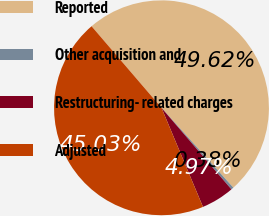Convert chart to OTSL. <chart><loc_0><loc_0><loc_500><loc_500><pie_chart><fcel>Reported<fcel>Other acquisition and<fcel>Restructuring- related charges<fcel>Adjusted<nl><fcel>49.62%<fcel>0.38%<fcel>4.97%<fcel>45.03%<nl></chart> 